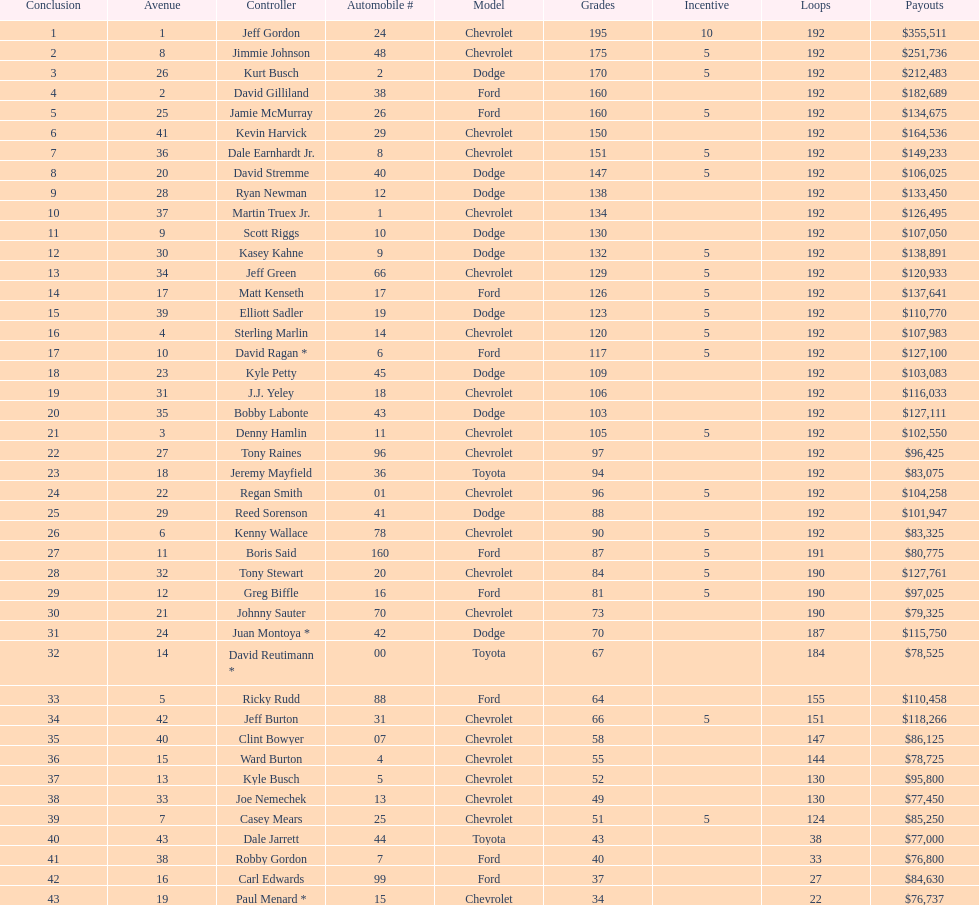Who got the most bonus points? Jeff Gordon. 